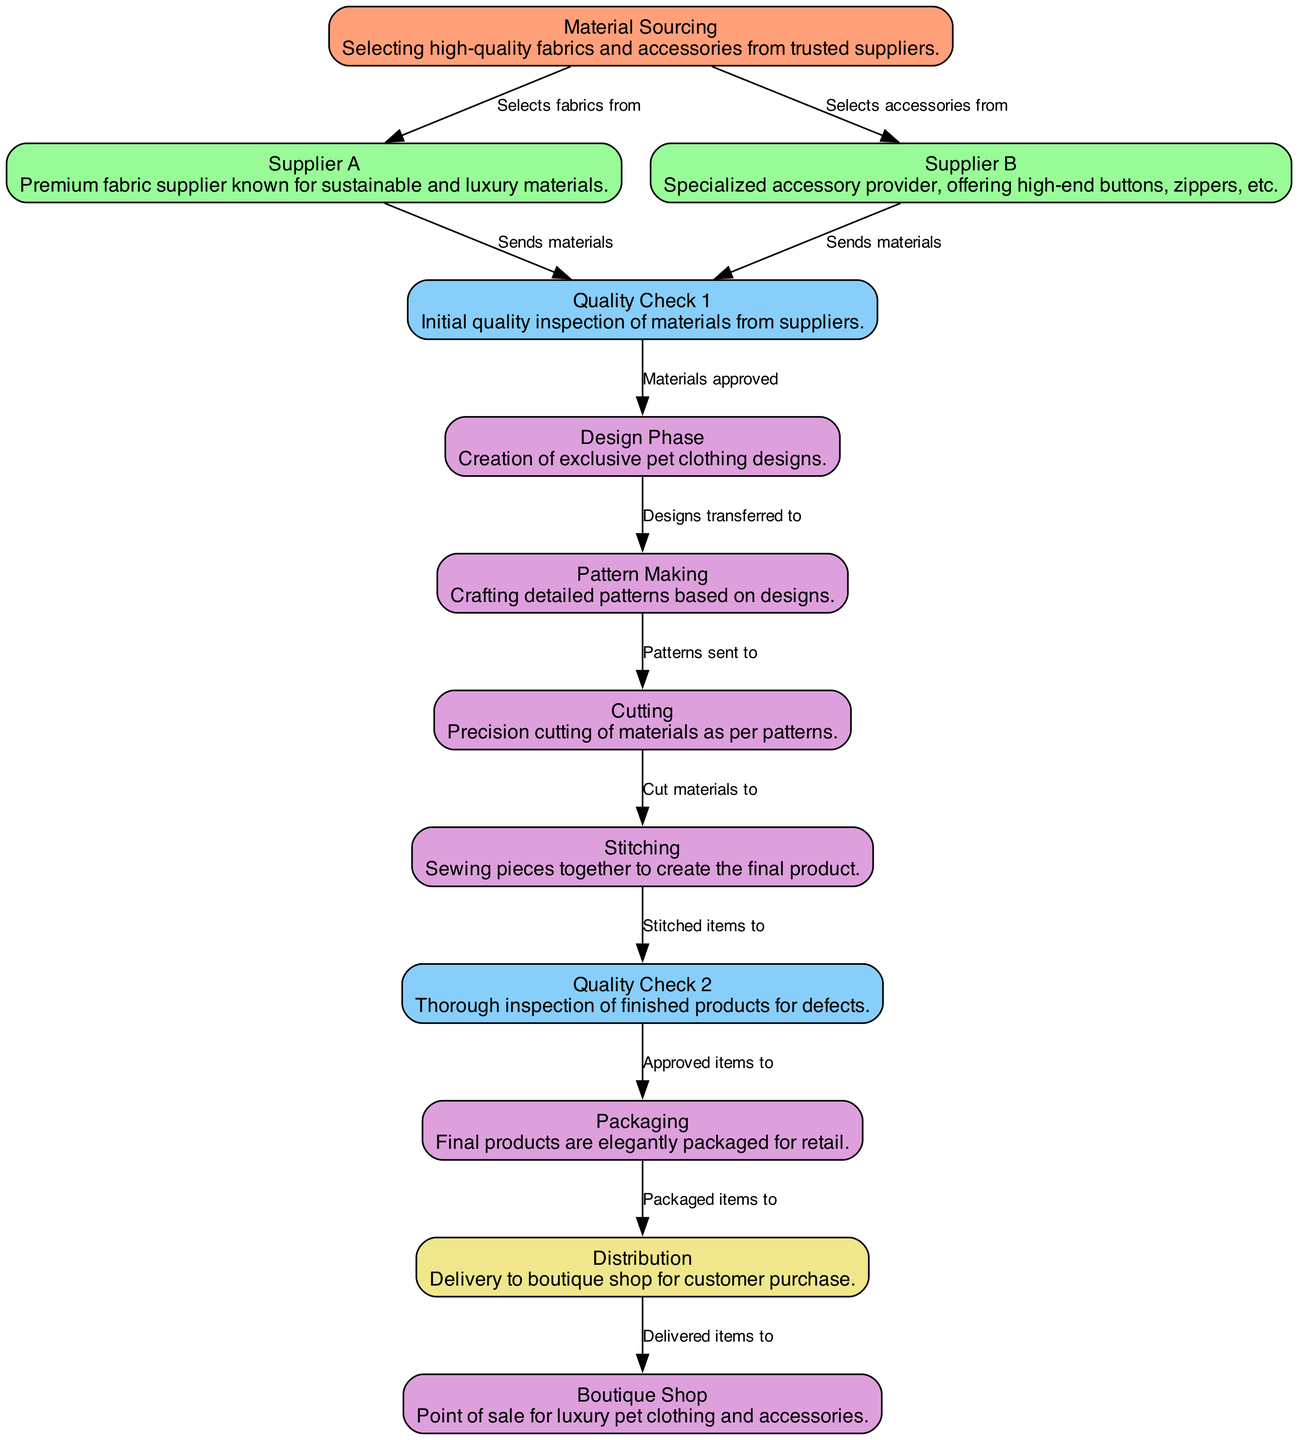What is the first step in the supply chain workflow? The diagram indicates that the first step is 'Material Sourcing,' where high-quality fabrics and accessories are selected from trusted suppliers.
Answer: Material Sourcing How many quality checks are displayed in the diagram? Upon examining the diagram, it can be noted that there are two quality checks labeled 'Quality Check 1' and 'Quality Check 2.'
Answer: 2 Which node follows the 'Pattern Making' node? The diagram shows that 'Cutting' is the next step that follows after 'Pattern Making.'
Answer: Cutting What is sent from 'Supplier A' to 'Quality Check 1'? According to the diagram, 'Supplier A' sends materials to 'Quality Check 1' for initial inspection.
Answer: Materials From which node do packaged items go to 'Distribution'? The diagram indicates that packaged items are sent to 'Distribution' directly from 'Packaging.'
Answer: Packaging What type of products undergo 'Quality Check 2'? The diagram clarifies that 'Stitched items' are the products that undergo 'Quality Check 2' to ensure there are no defects before packaging.
Answer: Stitched items Which node is a point of sale for luxury pet clothing and accessories? The diagram identifies 'Boutique Shop' as the point where customers purchase the final products.
Answer: Boutique Shop What type of items does 'Supplier B' provide? The diagram specifies that 'Supplier B' specializes in high-end accessories such as buttons, zippers, etc.
Answer: High-end accessories What happens if materials are not approved in 'Quality Check 1'? While the diagram does not explicitly state this, it implies that unapproved materials would not proceed to the design phase, resulting in a halt in production workflow.
Answer: Not proceed to design phase 